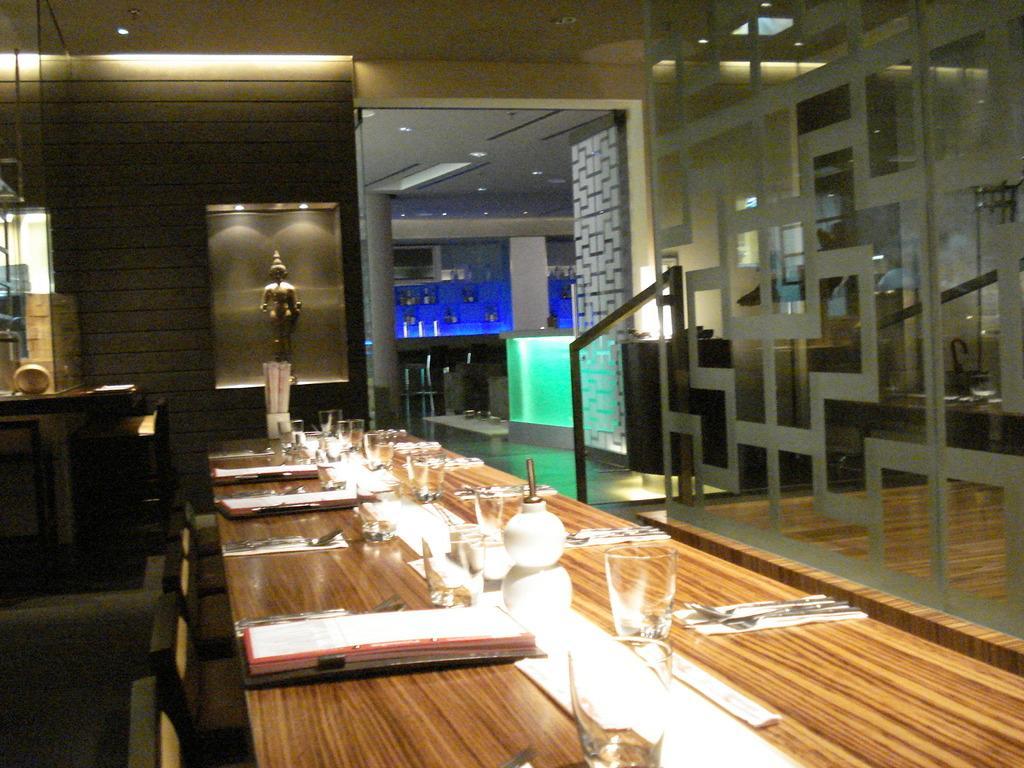Could you give a brief overview of what you see in this image? This is an inside view. Here I can see a table on which few glasses and some more objects are placed. Beside the table there are some empty chairs. In the background there is a sculpture in a box. On the top of the image I can see the lights. On the left side there is a table and wall. 